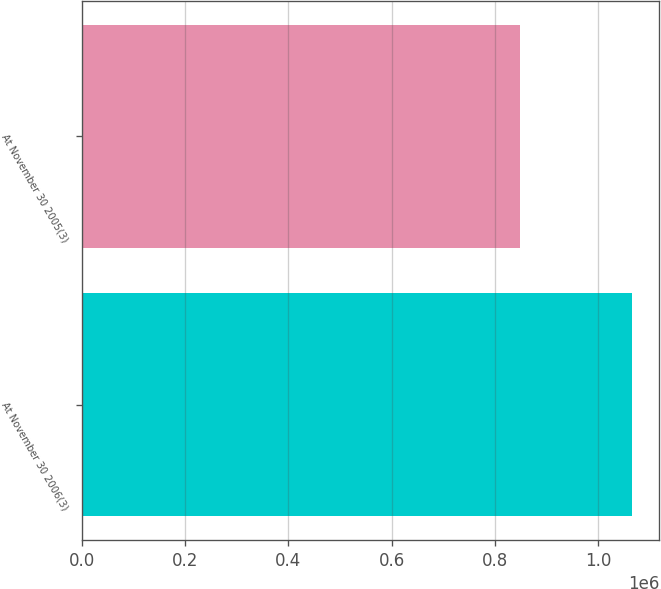<chart> <loc_0><loc_0><loc_500><loc_500><bar_chart><fcel>At November 30 2006(3)<fcel>At November 30 2005(3)<nl><fcel>1.06398e+06<fcel>848555<nl></chart> 